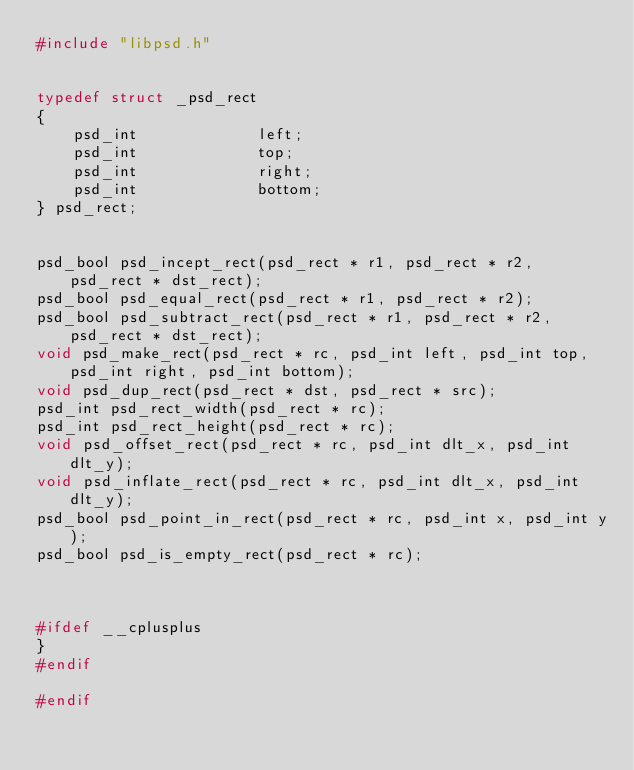Convert code to text. <code><loc_0><loc_0><loc_500><loc_500><_C_>#include "libpsd.h"


typedef struct _psd_rect
{
	psd_int 			left;
	psd_int 			top;
	psd_int 			right;
	psd_int 			bottom;
} psd_rect;


psd_bool psd_incept_rect(psd_rect * r1, psd_rect * r2, psd_rect * dst_rect);
psd_bool psd_equal_rect(psd_rect * r1, psd_rect * r2);
psd_bool psd_subtract_rect(psd_rect * r1, psd_rect * r2, psd_rect * dst_rect);
void psd_make_rect(psd_rect * rc, psd_int left, psd_int top, psd_int right, psd_int bottom);
void psd_dup_rect(psd_rect * dst, psd_rect * src);
psd_int psd_rect_width(psd_rect * rc);
psd_int psd_rect_height(psd_rect * rc);
void psd_offset_rect(psd_rect * rc, psd_int dlt_x, psd_int dlt_y);
void psd_inflate_rect(psd_rect * rc, psd_int dlt_x, psd_int dlt_y);
psd_bool psd_point_in_rect(psd_rect * rc, psd_int x, psd_int y);
psd_bool psd_is_empty_rect(psd_rect * rc);



#ifdef __cplusplus
}
#endif

#endif
</code> 